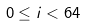<formula> <loc_0><loc_0><loc_500><loc_500>0 \leq i < 6 4</formula> 